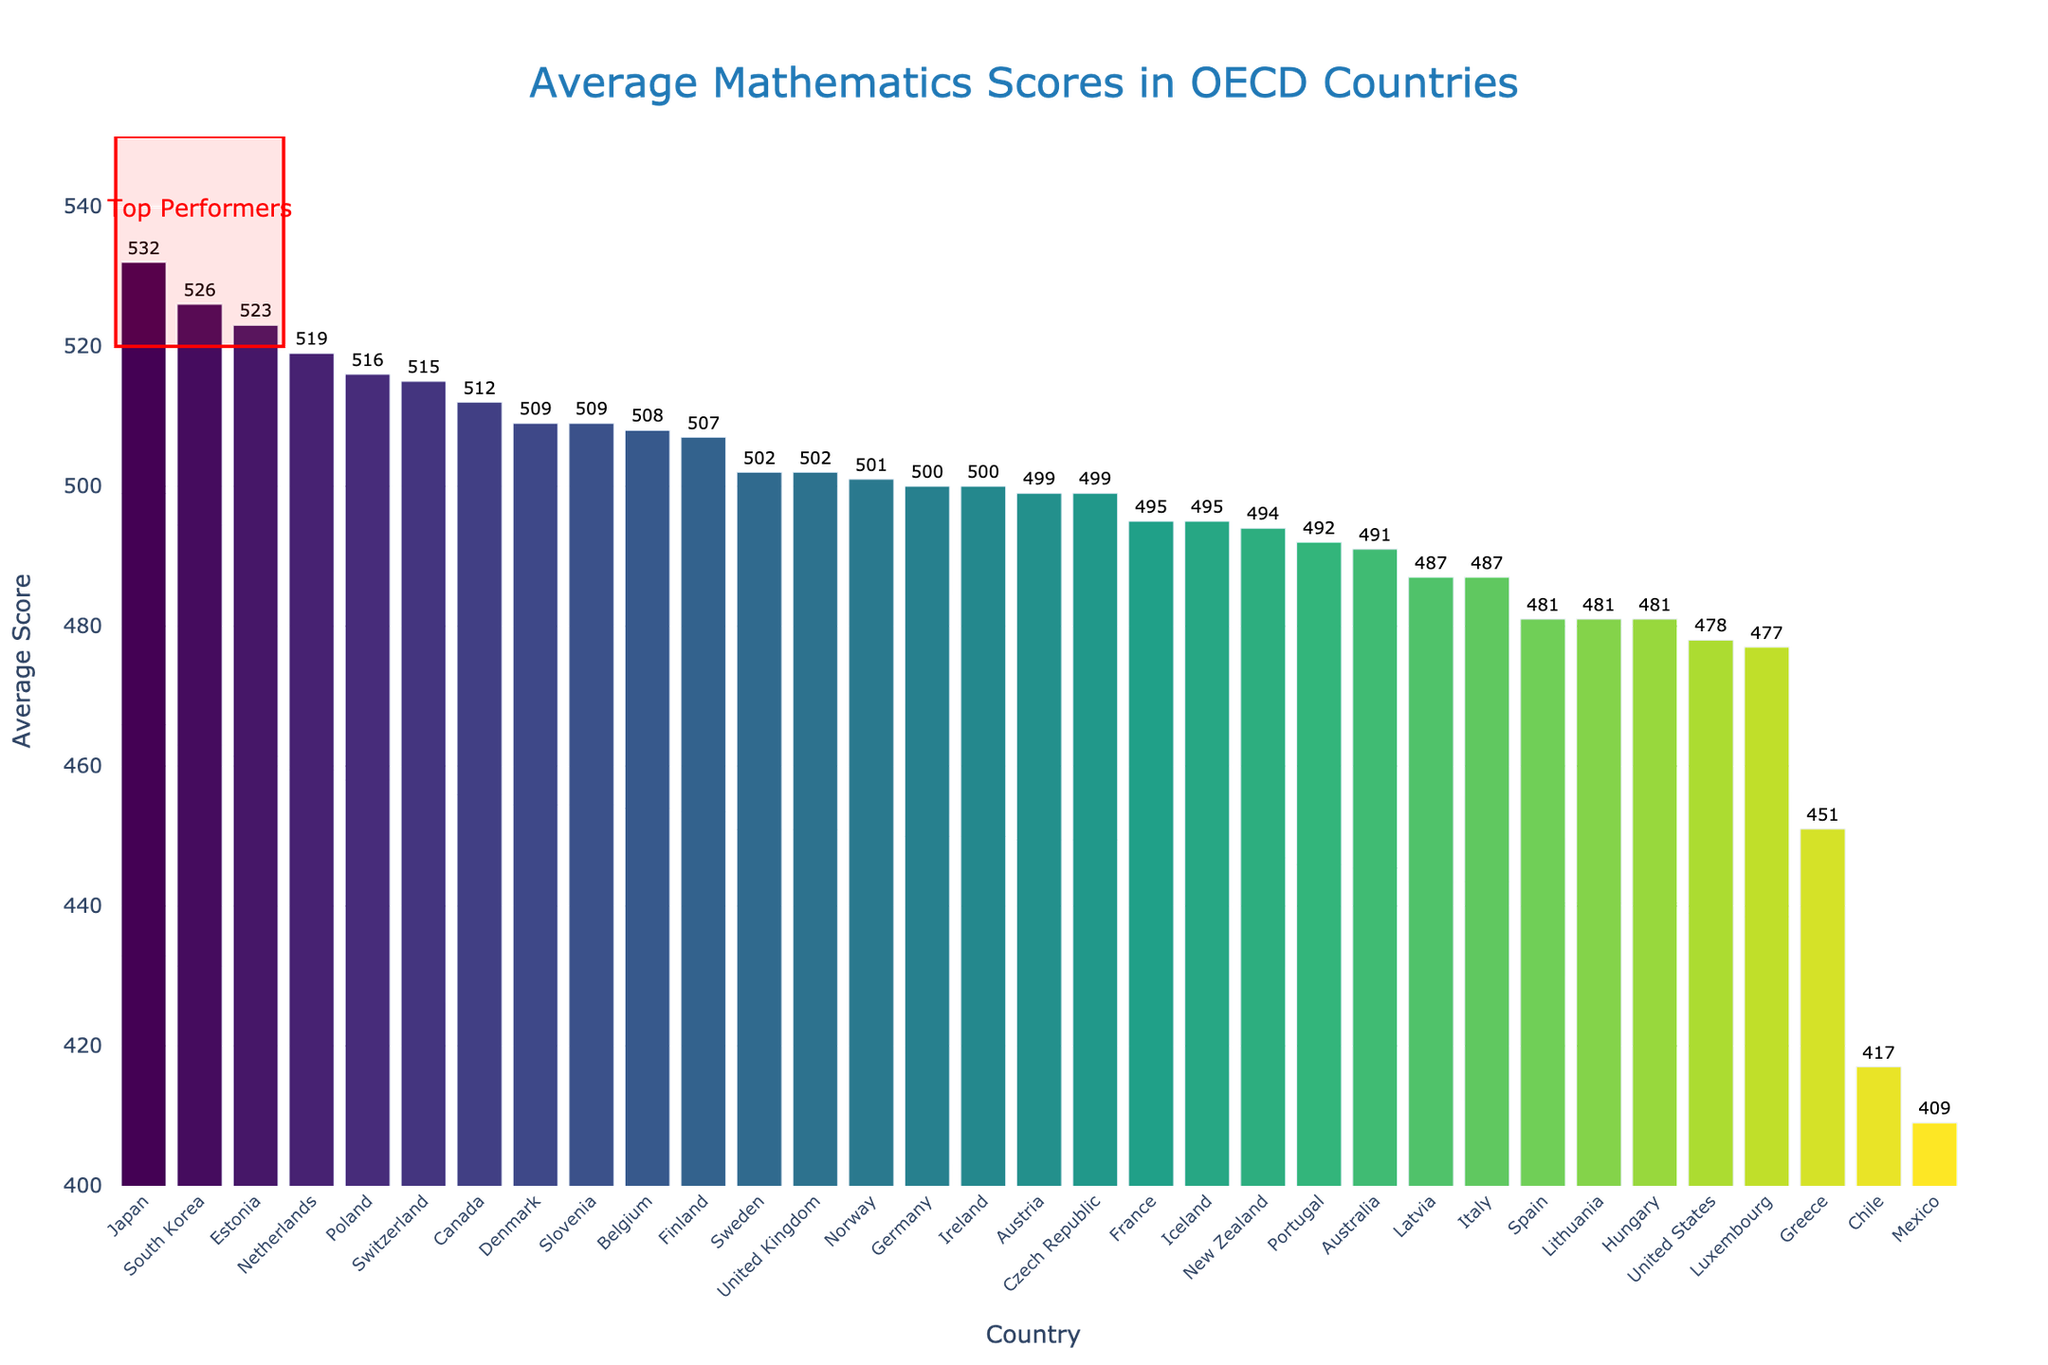Which country has the highest average mathematics score? The highest bar represents the country with the highest average mathematics score. The figure shows Japan as having the tallest bar, indicating the highest score.
Answer: Japan What is the range of average mathematics scores among these countries? The lowest score is represented by Mexico at the bottom of the chart with a score of 409, and the highest score is represented by Japan at the top of the chart with a score of 532. The range is calculated as 532 - 409.
Answer: 123 How many countries have an average mathematics score of 500 or more? By visually scanning the y-axis, locate the score of 500, and count the number of bars at this level or above, summing up all the applicable countries.
Answer: 17 Which countries fall within the "Top Performers" rectangle? The red rectangle highlights countries with scores between 520 and 550. The countries within this range based on their bar heights are Japan, South Korea, and Estonia.
Answer: Japan, South Korea, Estonia By how many points does the average mathematics score of Japan exceed that of the United States? Identify the scores for Japan (532) and the United States (478) and find the difference by subtracting the US score from the Japan score: 532 - 478.
Answer: 54 What is the average mathematics score of the countries represented outside the "Top Performers" rectangle below 500? Identify the countries with scores below 500, calculate the sum of their scores, and divide by the number of these countries. Countries are France (495), Iceland (495), New Zealand (494), Portugal (492), Australia (491), Latvia (487), Italy (487), Spain (481), Lithuania (481), Hungary (481), United States (478), Luxembourg (477), Greece (451), Chile (417), and Mexico (409). Average = (495+495+494+492+491+487+487+481+481+481+478+477+451+417+409) / 15 = 471.2.
Answer: 471.2 Which two countries have the closest average mathematics scores and what is their difference? By examining the bar heights closely, note that Austria and Czech Republic both have the same score of 499.
Answer: Austria and Czech Republic, 0 How does the average score of Finland compare to that of the United Kingdom? Check the bar heights and the values. Finland has a score of 507, while the United Kingdom has a score of 502. Calculate the difference: 507 - 502.
Answer: Finland is 5 points higher What is the median average mathematics score of the countries? Arrange the countries’ scores in ascending order and identify the middle score. With 34 countries, the median is the average of the 17th and 18th scores (500 and 499). Median = (500 + 499) / 2.
Answer: 499.5 How many countries have an average score below the overall average score of the depicted countries? First, calculate the total average score by summing all the scores and dividing by the number of countries, then count the countries below this average. The overall average score is: (sum of all scores) / 34 = 492.88. Countries with scores below this are Hungary, United States, Luxembourg, Greece, Chile, and Mexico.
Answer: 6 